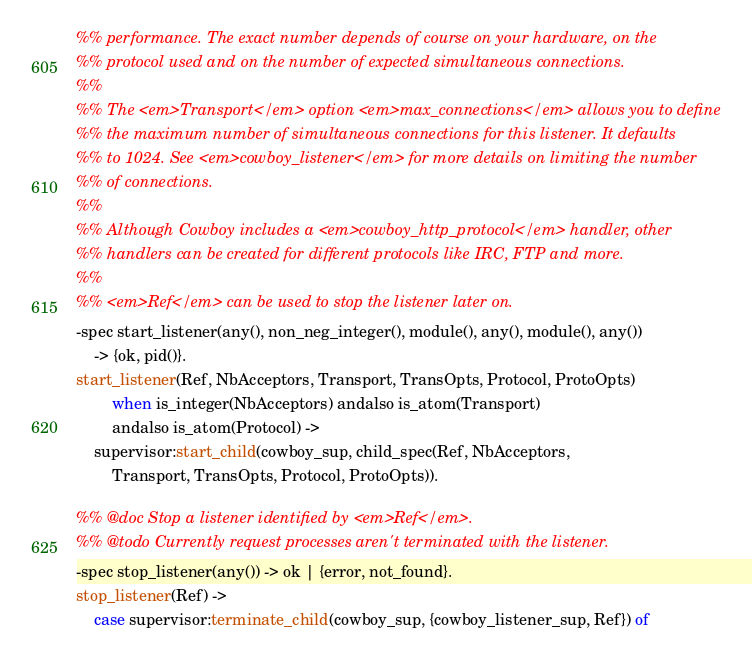<code> <loc_0><loc_0><loc_500><loc_500><_Erlang_>%% performance. The exact number depends of course on your hardware, on the
%% protocol used and on the number of expected simultaneous connections.
%%
%% The <em>Transport</em> option <em>max_connections</em> allows you to define
%% the maximum number of simultaneous connections for this listener. It defaults
%% to 1024. See <em>cowboy_listener</em> for more details on limiting the number
%% of connections.
%%
%% Although Cowboy includes a <em>cowboy_http_protocol</em> handler, other
%% handlers can be created for different protocols like IRC, FTP and more.
%%
%% <em>Ref</em> can be used to stop the listener later on.
-spec start_listener(any(), non_neg_integer(), module(), any(), module(), any())
	-> {ok, pid()}.
start_listener(Ref, NbAcceptors, Transport, TransOpts, Protocol, ProtoOpts)
		when is_integer(NbAcceptors) andalso is_atom(Transport)
		andalso is_atom(Protocol) ->
	supervisor:start_child(cowboy_sup, child_spec(Ref, NbAcceptors,
		Transport, TransOpts, Protocol, ProtoOpts)).

%% @doc Stop a listener identified by <em>Ref</em>.
%% @todo Currently request processes aren't terminated with the listener.
-spec stop_listener(any()) -> ok | {error, not_found}.
stop_listener(Ref) ->
	case supervisor:terminate_child(cowboy_sup, {cowboy_listener_sup, Ref}) of</code> 